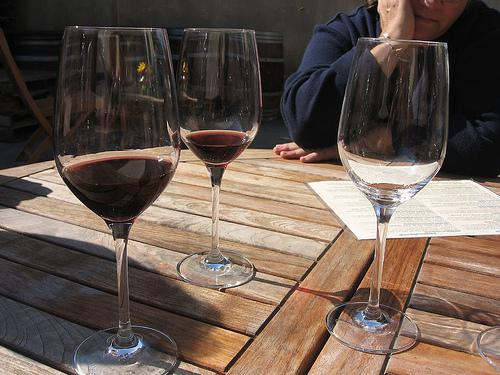Question: how many glasses are on the table?
Choices:
A. Two.
B. Four.
C. Five.
D. Three.
Answer with the letter. Answer: D Question: where was this picture taken?
Choices:
A. Event.
B. Party.
C. School.
D. Post office.
Answer with the letter. Answer: B Question: how was this picture lit?
Choices:
A. Sunlight.
B. Candle light.
C. Lamps.
D. Reflected light.
Answer with the letter. Answer: A Question: what is in the glasses?
Choices:
A. Pop.
B. Wine.
C. Juice.
D. Water.
Answer with the letter. Answer: B Question: how many glasses have wine in them?
Choices:
A. One.
B. Two.
C. Three.
D. Four.
Answer with the letter. Answer: B 